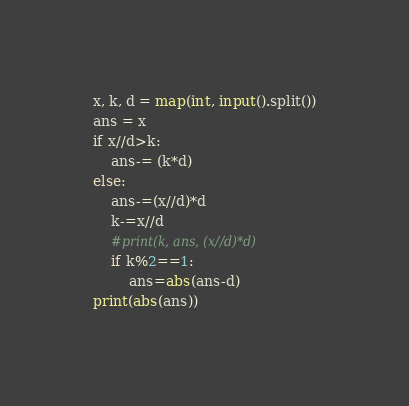Convert code to text. <code><loc_0><loc_0><loc_500><loc_500><_Python_>x, k, d = map(int, input().split())
ans = x
if x//d>k:
    ans-= (k*d)
else:
    ans-=(x//d)*d
    k-=x//d
    #print(k, ans, (x//d)*d)
    if k%2==1:
        ans=abs(ans-d)
print(abs(ans))</code> 